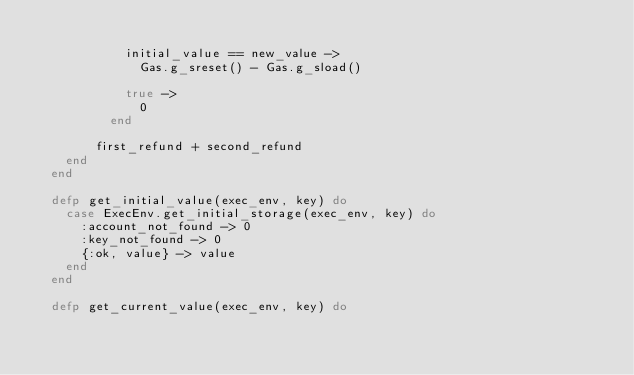Convert code to text. <code><loc_0><loc_0><loc_500><loc_500><_Elixir_>
            initial_value == new_value ->
              Gas.g_sreset() - Gas.g_sload()

            true ->
              0
          end

        first_refund + second_refund
    end
  end

  defp get_initial_value(exec_env, key) do
    case ExecEnv.get_initial_storage(exec_env, key) do
      :account_not_found -> 0
      :key_not_found -> 0
      {:ok, value} -> value
    end
  end

  defp get_current_value(exec_env, key) do</code> 